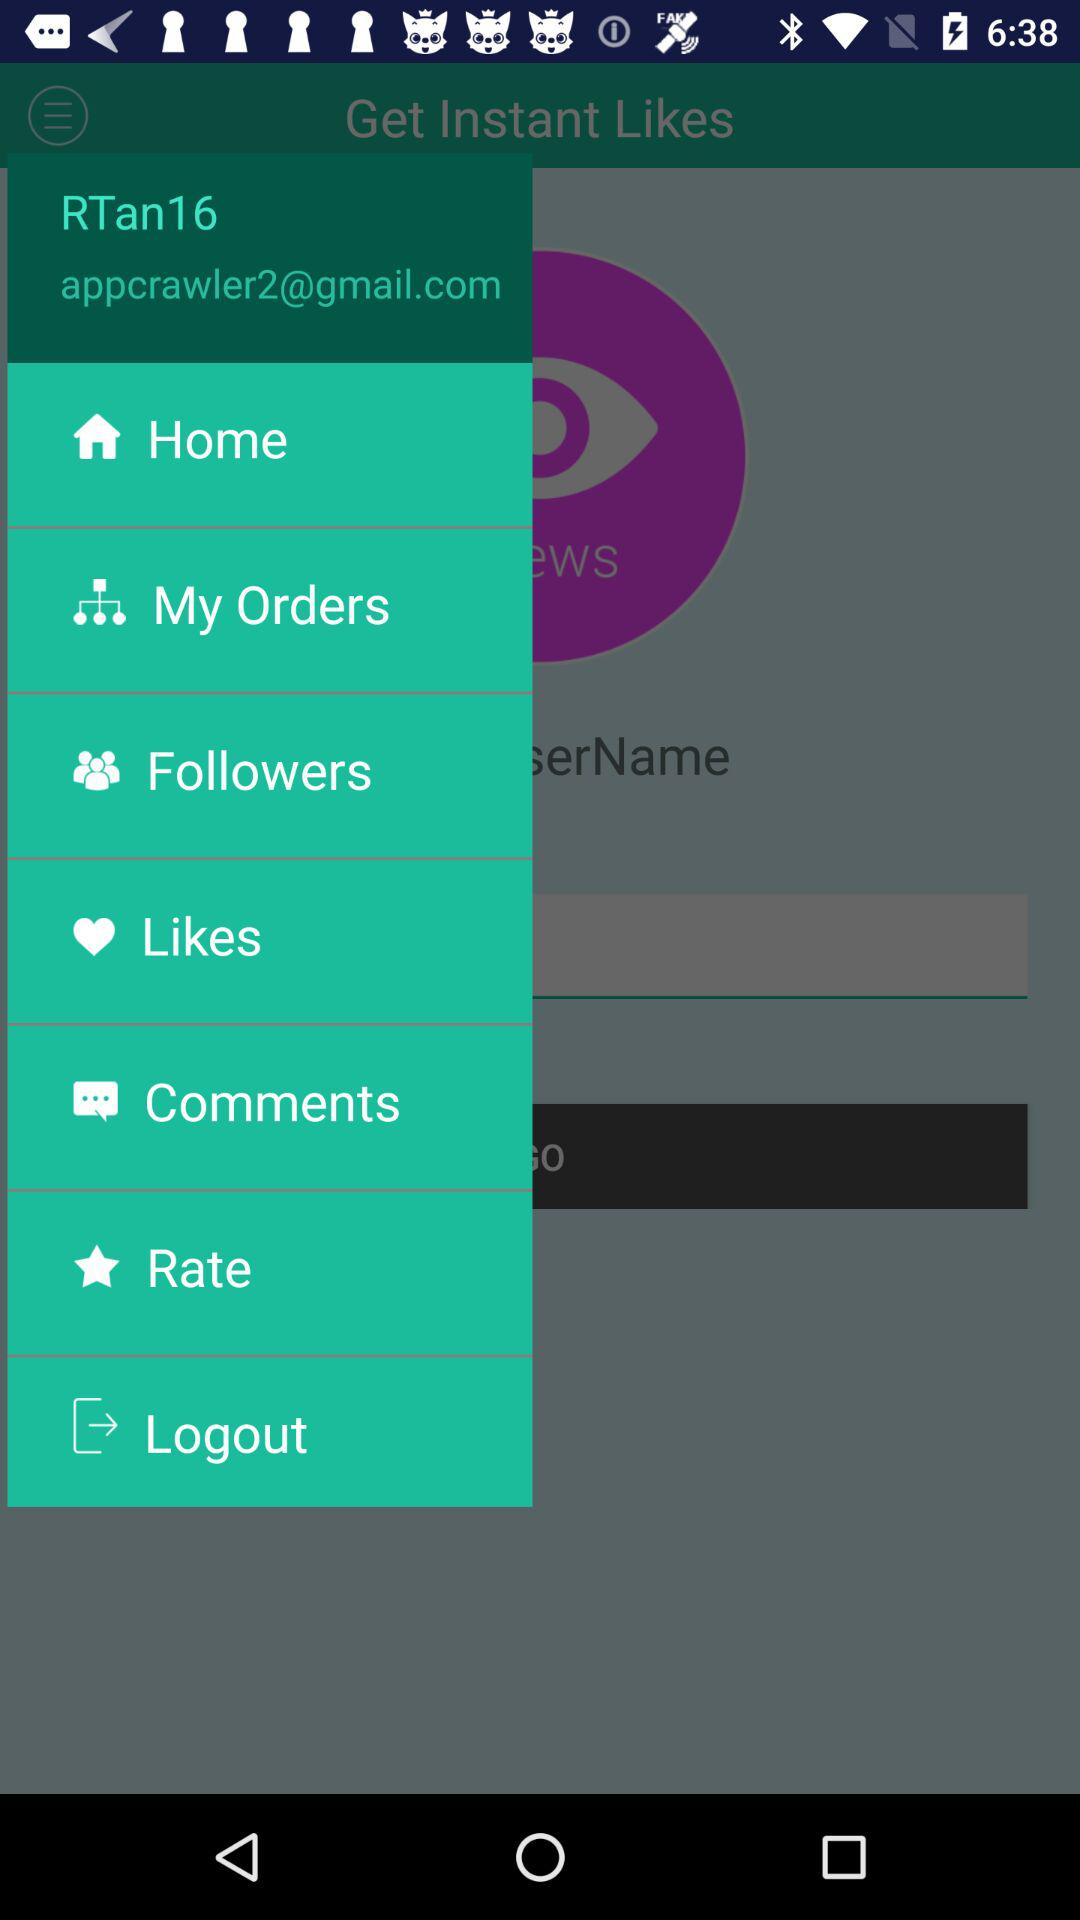What is the email address? The email address is "appcrawler2@gmail.com". 